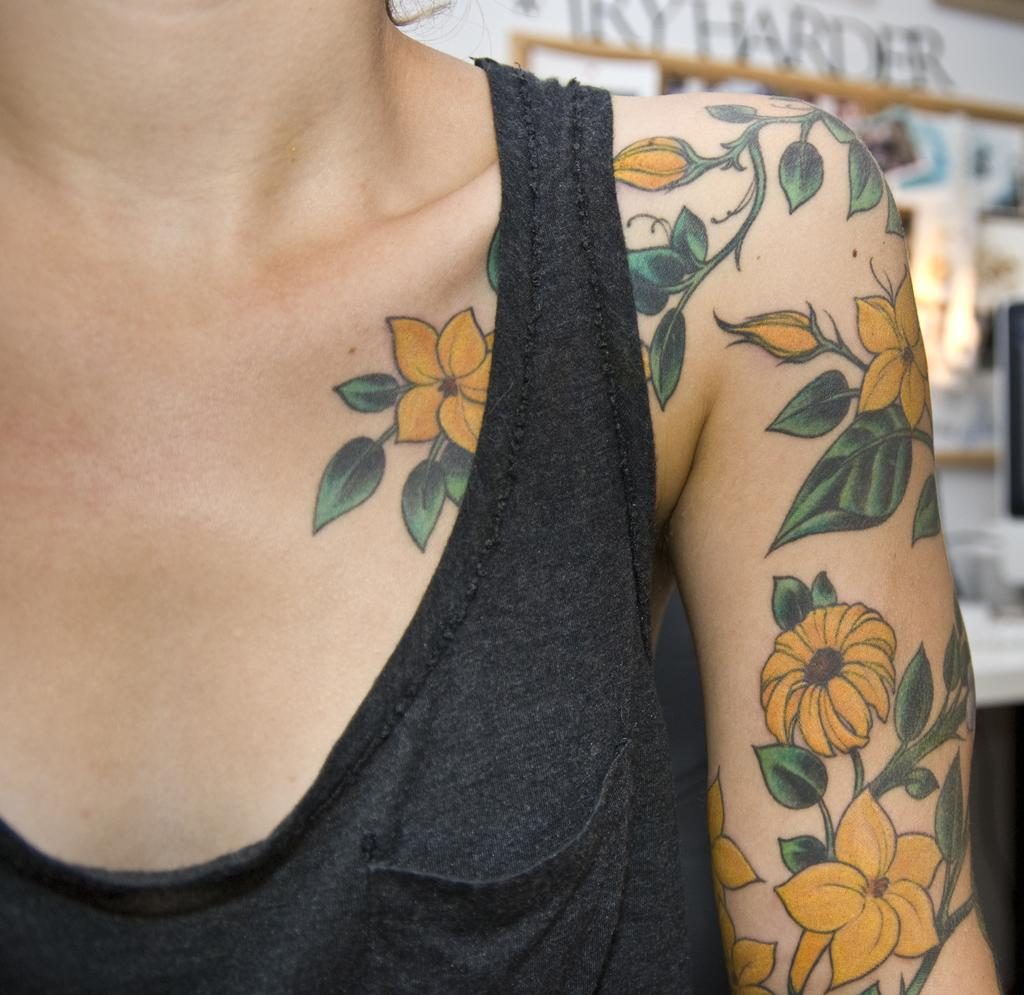Who is the main subject in the image? There is a lady in the image. What can be seen on the lady's body? The lady has a tattoo on her shoulder. What is visible in the background of the image? There is text and photos on the wall in the background of the image. What type of zinc is present in the lady's voice in the image? There is no mention of zinc or any audible element in the image, as it is a still photograph. 